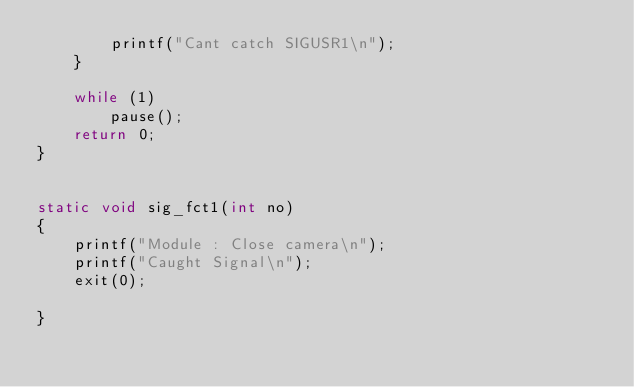<code> <loc_0><loc_0><loc_500><loc_500><_C_>        printf("Cant catch SIGUSR1\n");
    }

    while (1)
        pause();
    return 0;
}


static void sig_fct1(int no)
{
    printf("Module : Close camera\n");
    printf("Caught Signal\n");
    exit(0);
          
}

</code> 